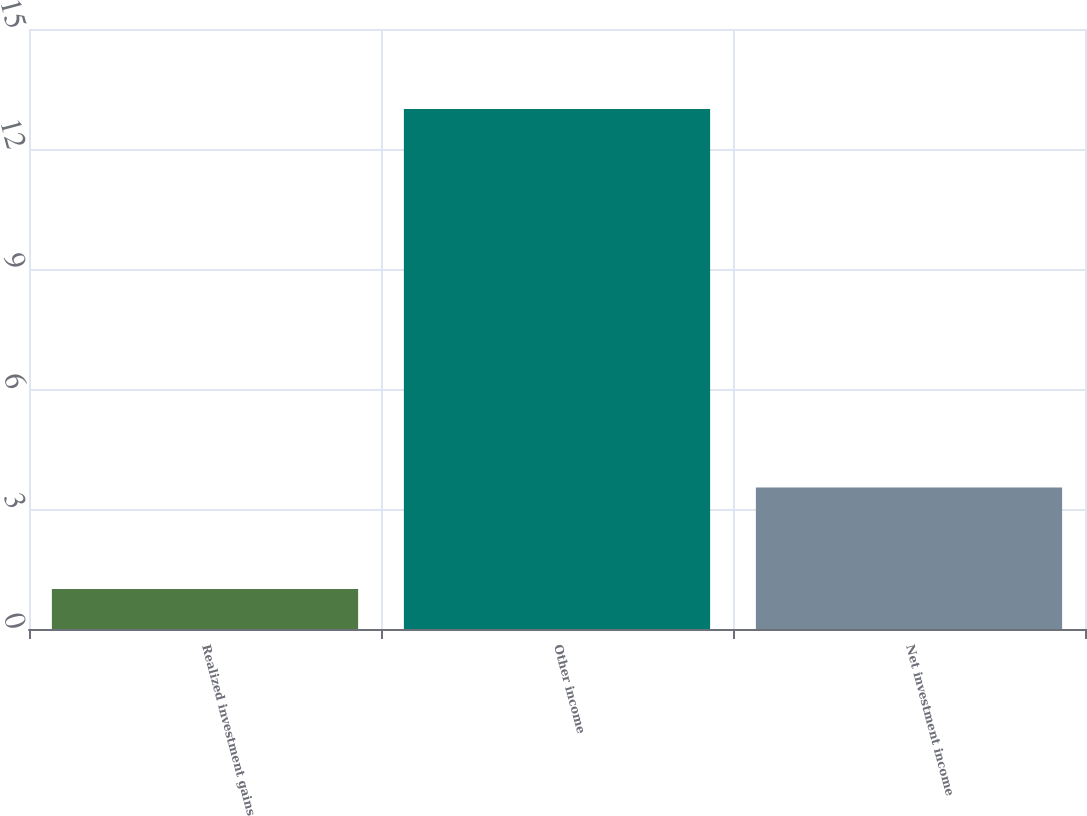<chart> <loc_0><loc_0><loc_500><loc_500><bar_chart><fcel>Realized investment gains<fcel>Other income<fcel>Net investment income<nl><fcel>1<fcel>13<fcel>3.54<nl></chart> 